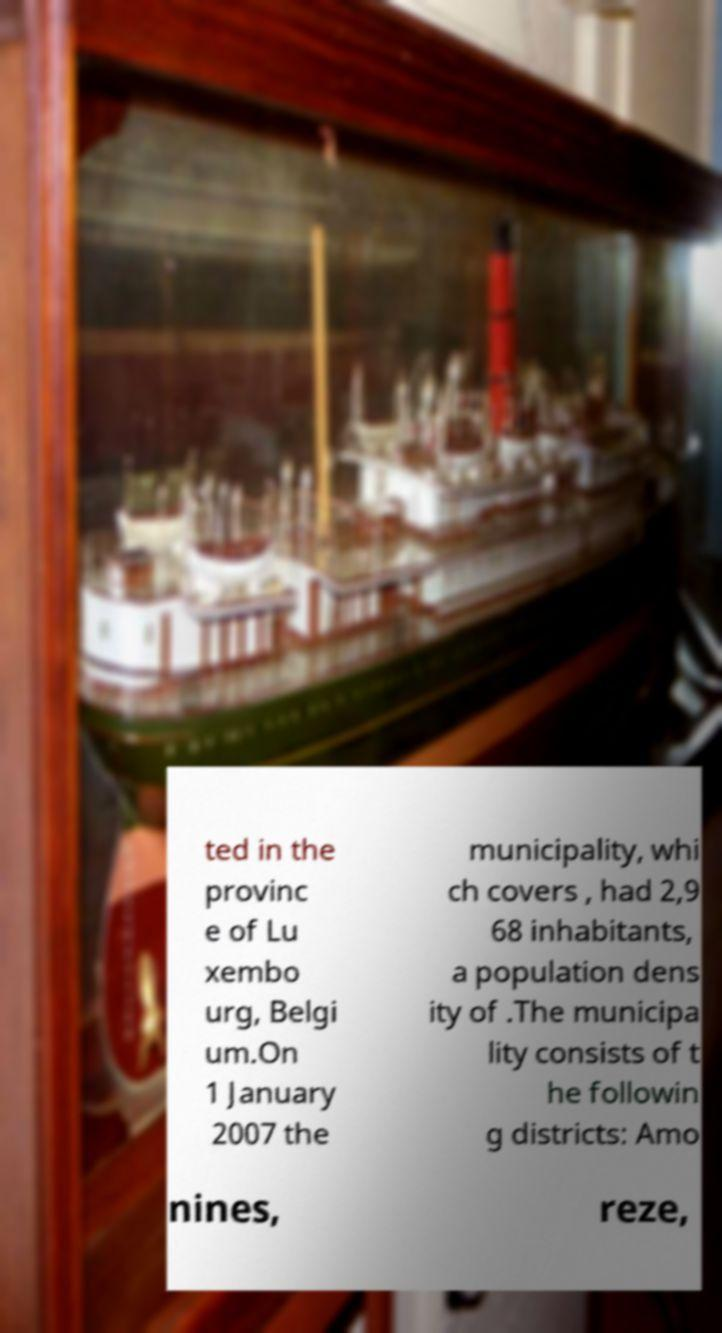Could you extract and type out the text from this image? ted in the provinc e of Lu xembo urg, Belgi um.On 1 January 2007 the municipality, whi ch covers , had 2,9 68 inhabitants, a population dens ity of .The municipa lity consists of t he followin g districts: Amo nines, reze, 